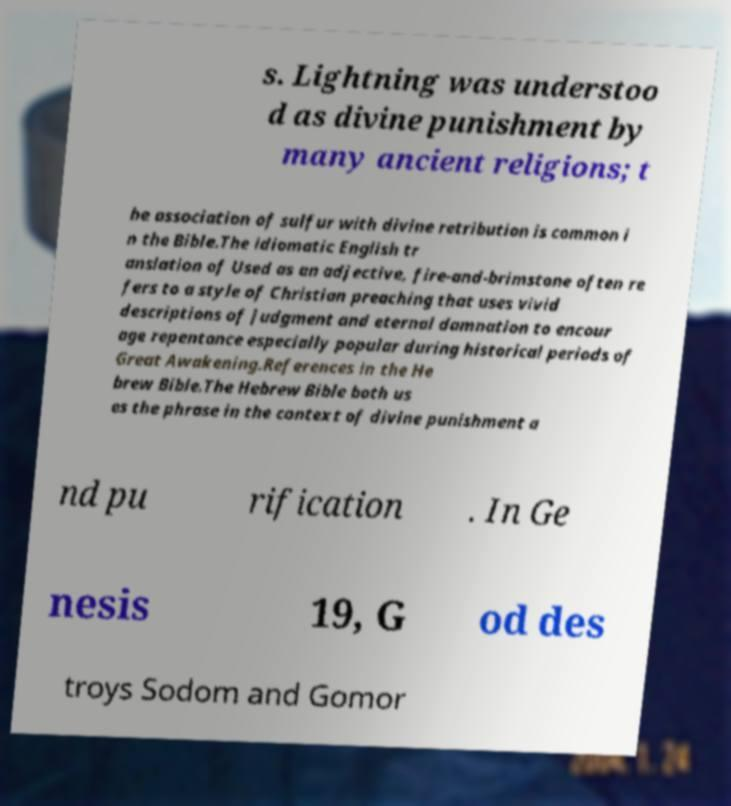I need the written content from this picture converted into text. Can you do that? s. Lightning was understoo d as divine punishment by many ancient religions; t he association of sulfur with divine retribution is common i n the Bible.The idiomatic English tr anslation of Used as an adjective, fire-and-brimstone often re fers to a style of Christian preaching that uses vivid descriptions of judgment and eternal damnation to encour age repentance especially popular during historical periods of Great Awakening.References in the He brew Bible.The Hebrew Bible both us es the phrase in the context of divine punishment a nd pu rification . In Ge nesis 19, G od des troys Sodom and Gomor 